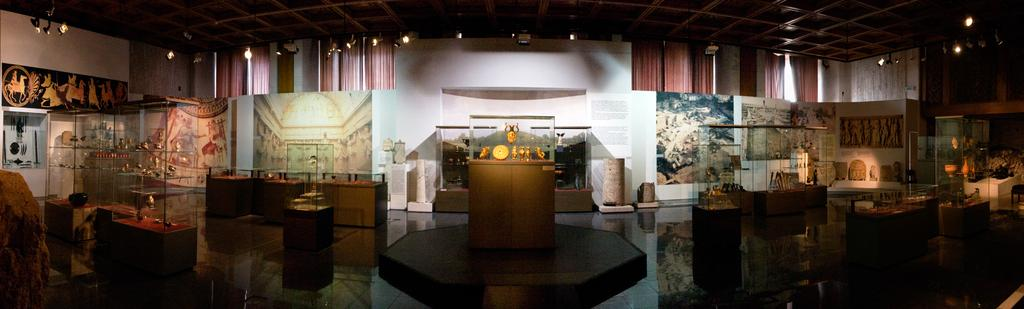What type of containers are present in the image? There are glasses boxes in the image. What can be found inside the glasses boxes? There are objects inside the glasses boxes. What is attached to the wall in the image? There are frames attached to the wall in the image. What color are the curtains in the image? The curtains in the image are brown. What can be seen providing illumination in the image? There are lights visible in the image. How does the star affect the trip in the image? There is no star or trip present in the image, so this question cannot be answered. 